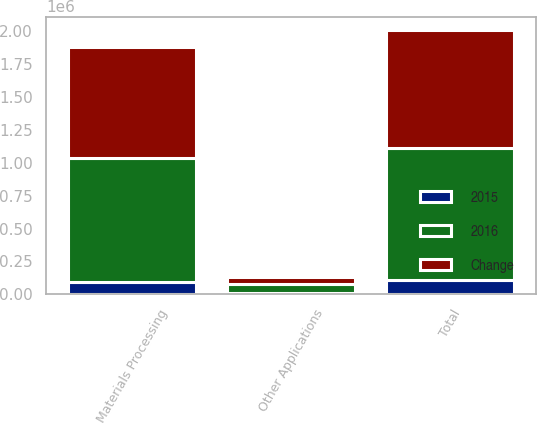Convert chart to OTSL. <chart><loc_0><loc_0><loc_500><loc_500><stacked_bar_chart><ecel><fcel>Materials Processing<fcel>Other Applications<fcel>Total<nl><fcel>2016<fcel>942119<fcel>64054<fcel>1.00617e+06<nl><fcel>Change<fcel>849335<fcel>51930<fcel>901265<nl><fcel>2015<fcel>92784<fcel>12124<fcel>104908<nl></chart> 